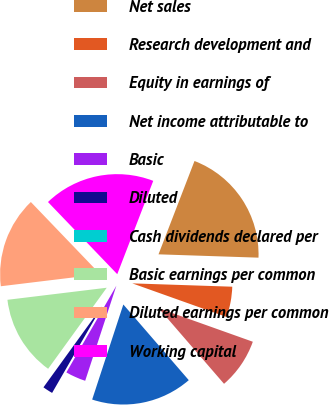Convert chart. <chart><loc_0><loc_0><loc_500><loc_500><pie_chart><fcel>Net sales<fcel>Research development and<fcel>Equity in earnings of<fcel>Net income attributable to<fcel>Basic<fcel>Diluted<fcel>Cash dividends declared per<fcel>Basic earnings per common<fcel>Diluted earnings per common<fcel>Working capital<nl><fcel>19.67%<fcel>4.92%<fcel>8.2%<fcel>16.39%<fcel>3.28%<fcel>1.64%<fcel>0.0%<fcel>13.11%<fcel>14.75%<fcel>18.03%<nl></chart> 